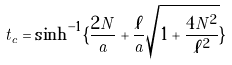Convert formula to latex. <formula><loc_0><loc_0><loc_500><loc_500>t _ { c } = \sinh ^ { - 1 } \{ \frac { 2 N } { a } + \frac { \ell } { a } \sqrt { 1 + \frac { 4 N ^ { 2 } } { \ell ^ { 2 } } } \}</formula> 